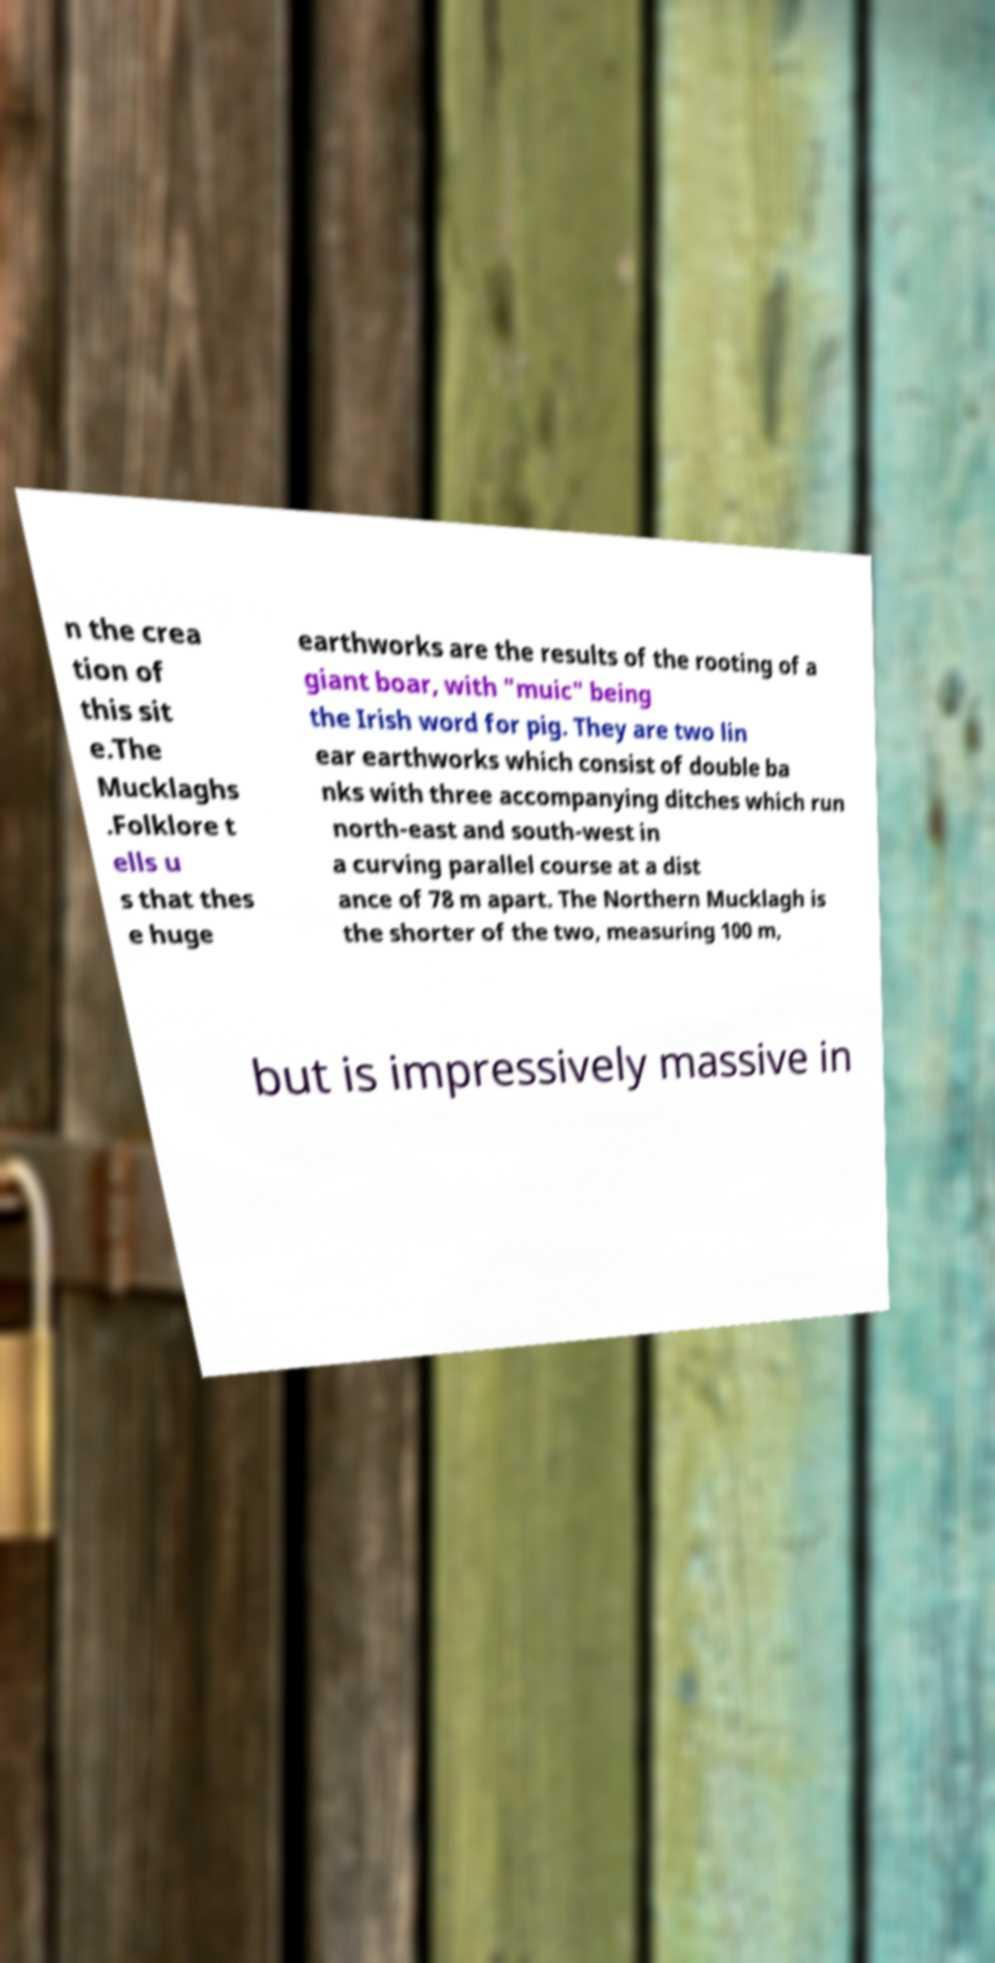Can you accurately transcribe the text from the provided image for me? n the crea tion of this sit e.The Mucklaghs .Folklore t ells u s that thes e huge earthworks are the results of the rooting of a giant boar, with "muic" being the Irish word for pig. They are two lin ear earthworks which consist of double ba nks with three accompanying ditches which run north-east and south-west in a curving parallel course at a dist ance of 78 m apart. The Northern Mucklagh is the shorter of the two, measuring 100 m, but is impressively massive in 